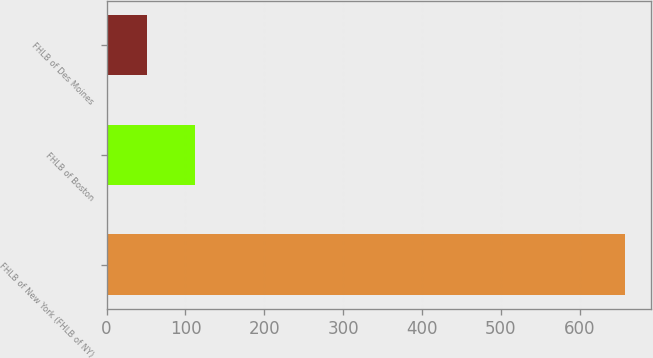Convert chart. <chart><loc_0><loc_0><loc_500><loc_500><bar_chart><fcel>FHLB of New York (FHLB of NY)<fcel>FHLB of Boston<fcel>FHLB of Des Moines<nl><fcel>658<fcel>111.7<fcel>51<nl></chart> 